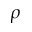Convert formula to latex. <formula><loc_0><loc_0><loc_500><loc_500>\rho</formula> 